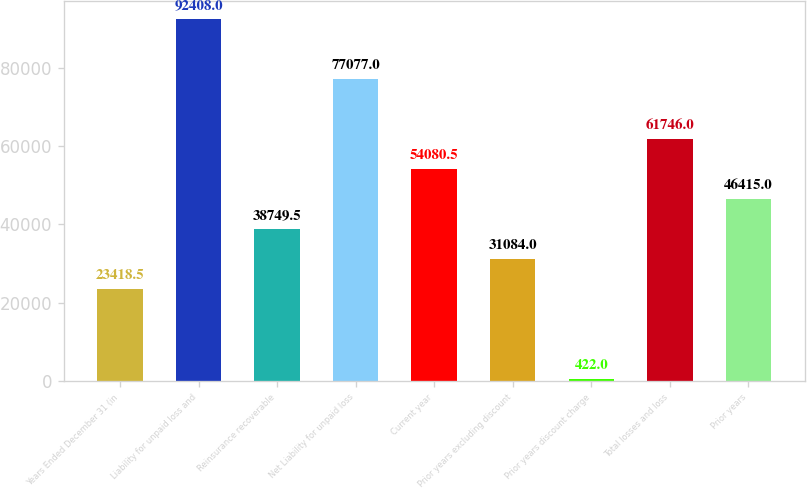<chart> <loc_0><loc_0><loc_500><loc_500><bar_chart><fcel>Years Ended December 31 (in<fcel>Liability for unpaid loss and<fcel>Reinsurance recoverable<fcel>Net Liability for unpaid loss<fcel>Current year<fcel>Prior years excluding discount<fcel>Prior years discount charge<fcel>Total losses and loss<fcel>Prior years<nl><fcel>23418.5<fcel>92408<fcel>38749.5<fcel>77077<fcel>54080.5<fcel>31084<fcel>422<fcel>61746<fcel>46415<nl></chart> 